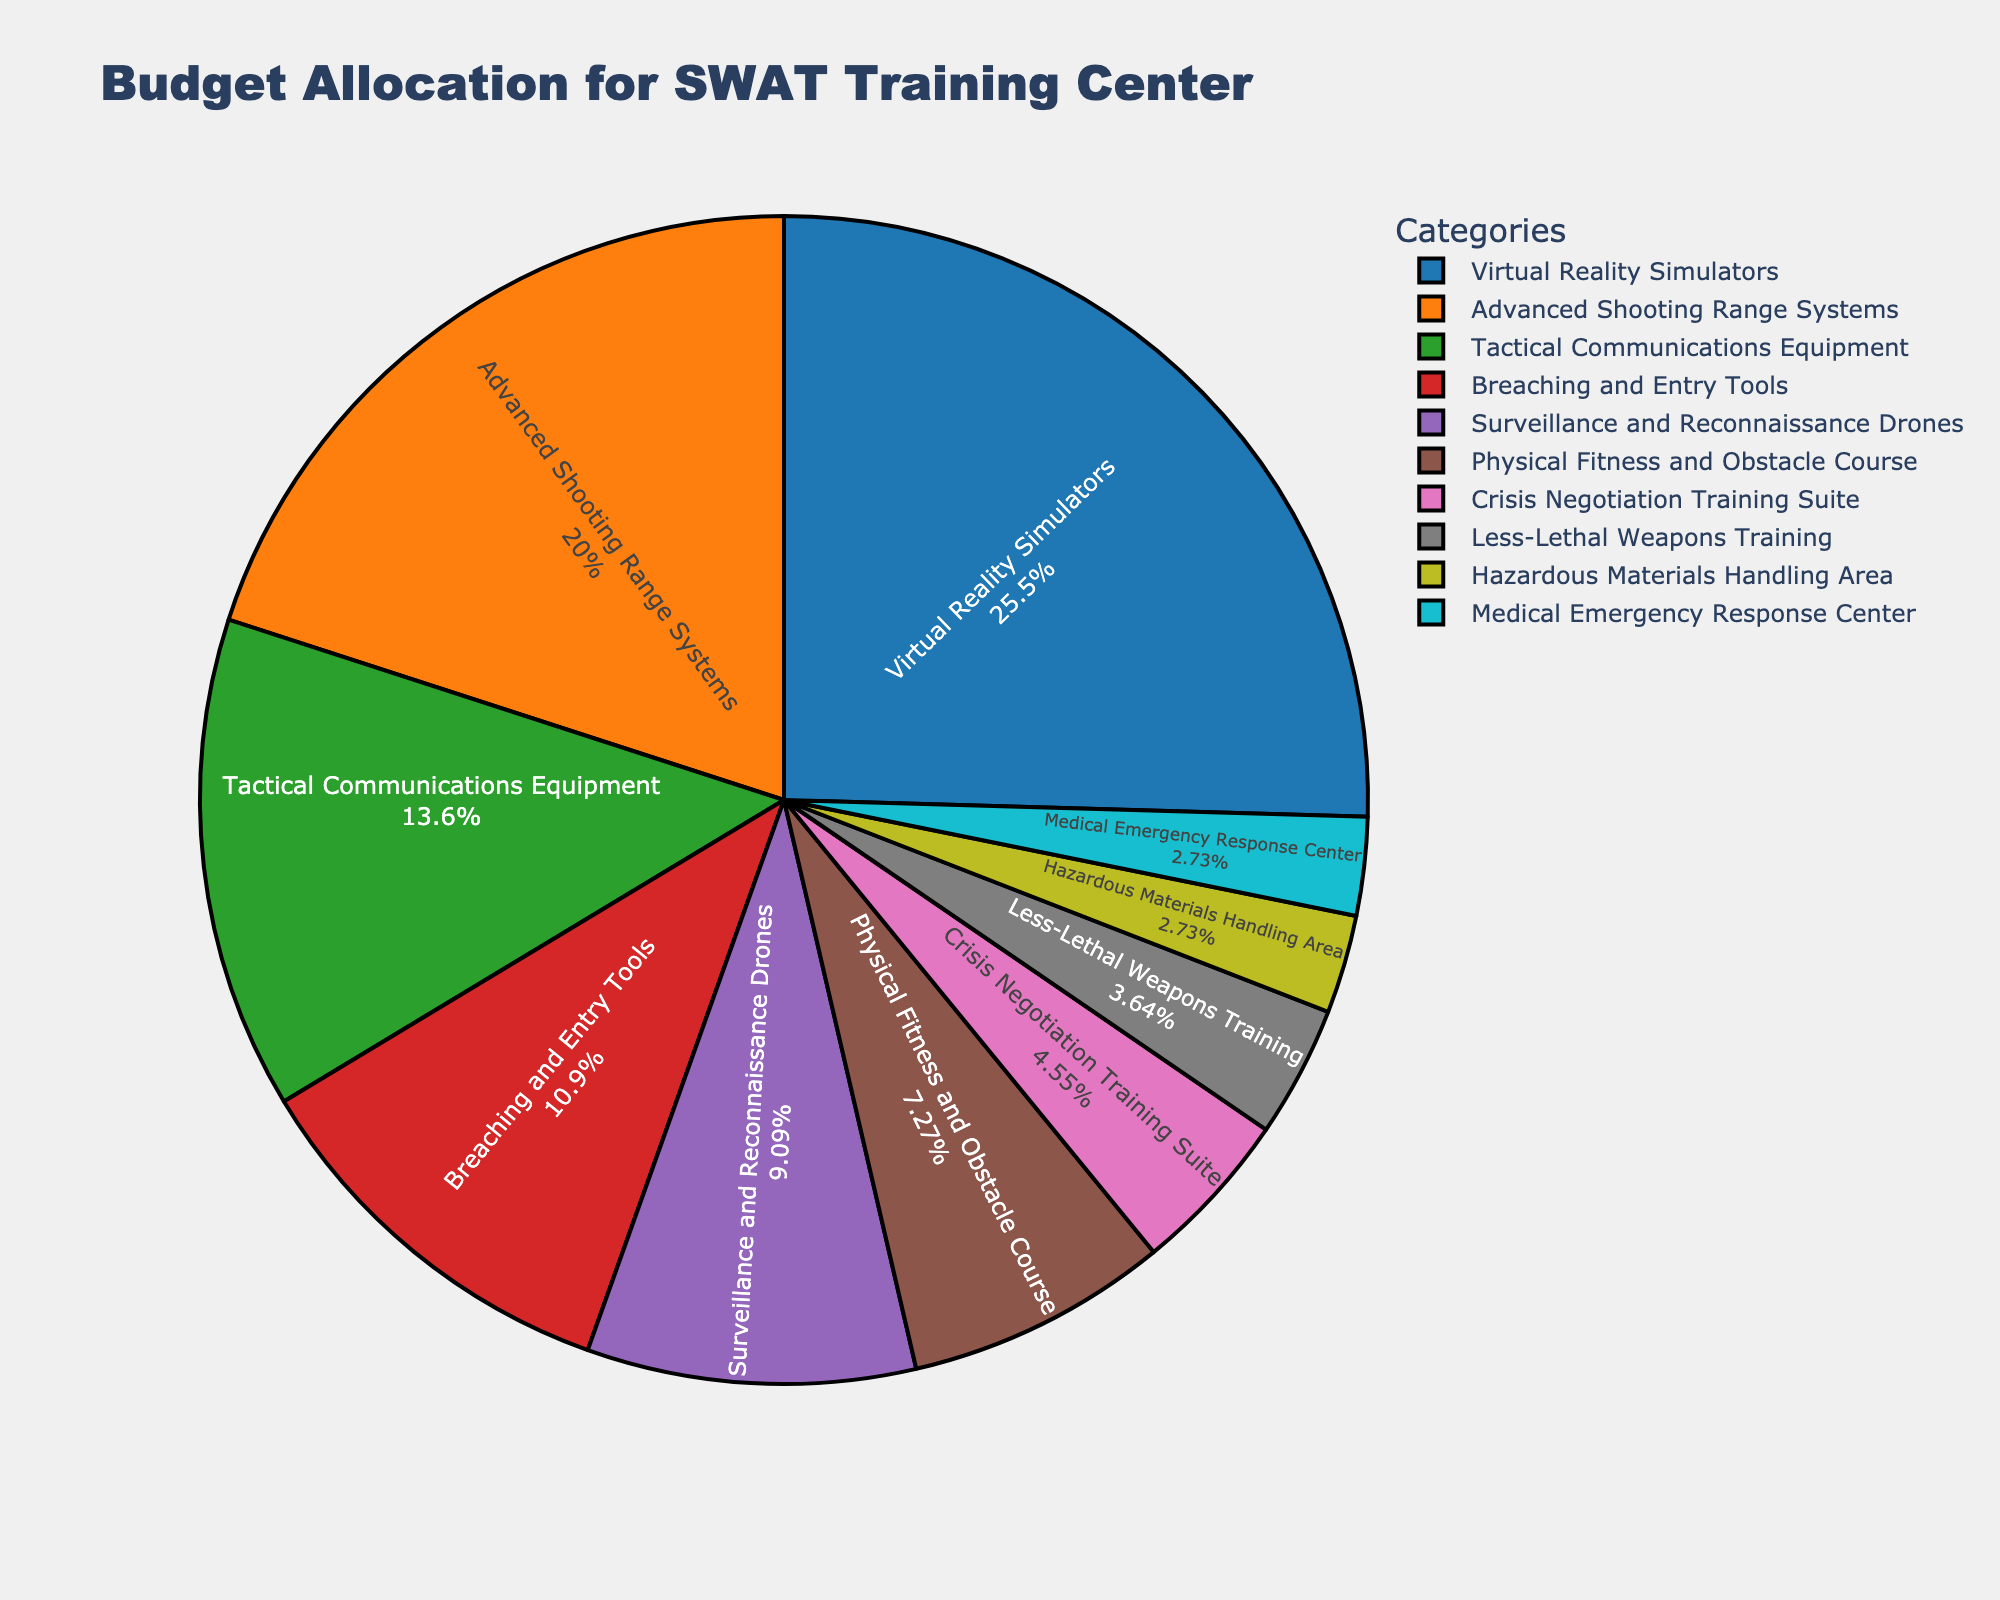What percentage of the budget is allocated to Virtual Reality Simulators? The pie chart shows each category and its corresponding percentage value inside each segment. The segment labelled "Virtual Reality Simulators" shows a percentage.
Answer: 28% Which category has the smallest budget allocation? The pie chart segments depict different categories along with their percentages. The smallest percentage value corresponds to the smallest budget allocation.
Answer: Medical Emergency Response Center and Hazardous Materials Handling Area How much more budget is allocated to Advanced Shooting Range Systems compared to Crisis Negotiation Training Suite? From the pie chart, find the budget allocation for both categories: Advanced Shooting Range Systems (22%) and Crisis Negotiation Training Suite (5%). Subtract the smaller percentage from the larger one.
Answer: 17% What is the total budget allocation for Tactical Communications Equipment and Breaching and Entry Tools combined? Locate the segments for "Tactical Communications Equipment" (15%) and "Breaching and Entry Tools" (12%). Add these percentages together.
Answer: 27% Between Surveillance and Reconnaissance Drones and Physical Fitness and Obstacle Course, which category has a higher budget allocation? Compare the percentage values depicted in the segments for "Surveillance and Reconnaissance Drones" (10%) and "Physical Fitness and Obstacle Course" (8%). Identify the higher value.
Answer: Surveillance and Reconnaissance Drones What is the combined budget allocation for categories with less than 10%? Identify segments with percentages less than 10%: "Physical Fitness and Obstacle Course" (8%), "Crisis Negotiation Training Suite" (5%), "Less-Lethal Weapons Training" (4%), "Hazardous Materials Handling Area" (3%), and "Medical Emergency Response Center" (3%). Sum these percentages.
Answer: 23% Which category has a budget allocation closest to 10%? Review the slices and their values to determine which percentage is nearest to 10%.
Answer: Surveillance and Reconnaissance Drones Is the combined budget for Breaching and Entry Tools and Less-Lethal Weapons Training greater or less than the budget for Tactical Communications Equipment? Breaching and Entry Tools (12%) plus Less-Lethal Weapons Training (4%) equals 16%. Compare this value to the percentage for Tactical Communications Equipment (15%).
Answer: Greater What color represents the Advanced Shooting Range Systems segment? Observe the color legend and match the category "Advanced Shooting Range Systems" with its corresponding color in the pie chart.
Answer: Orange 